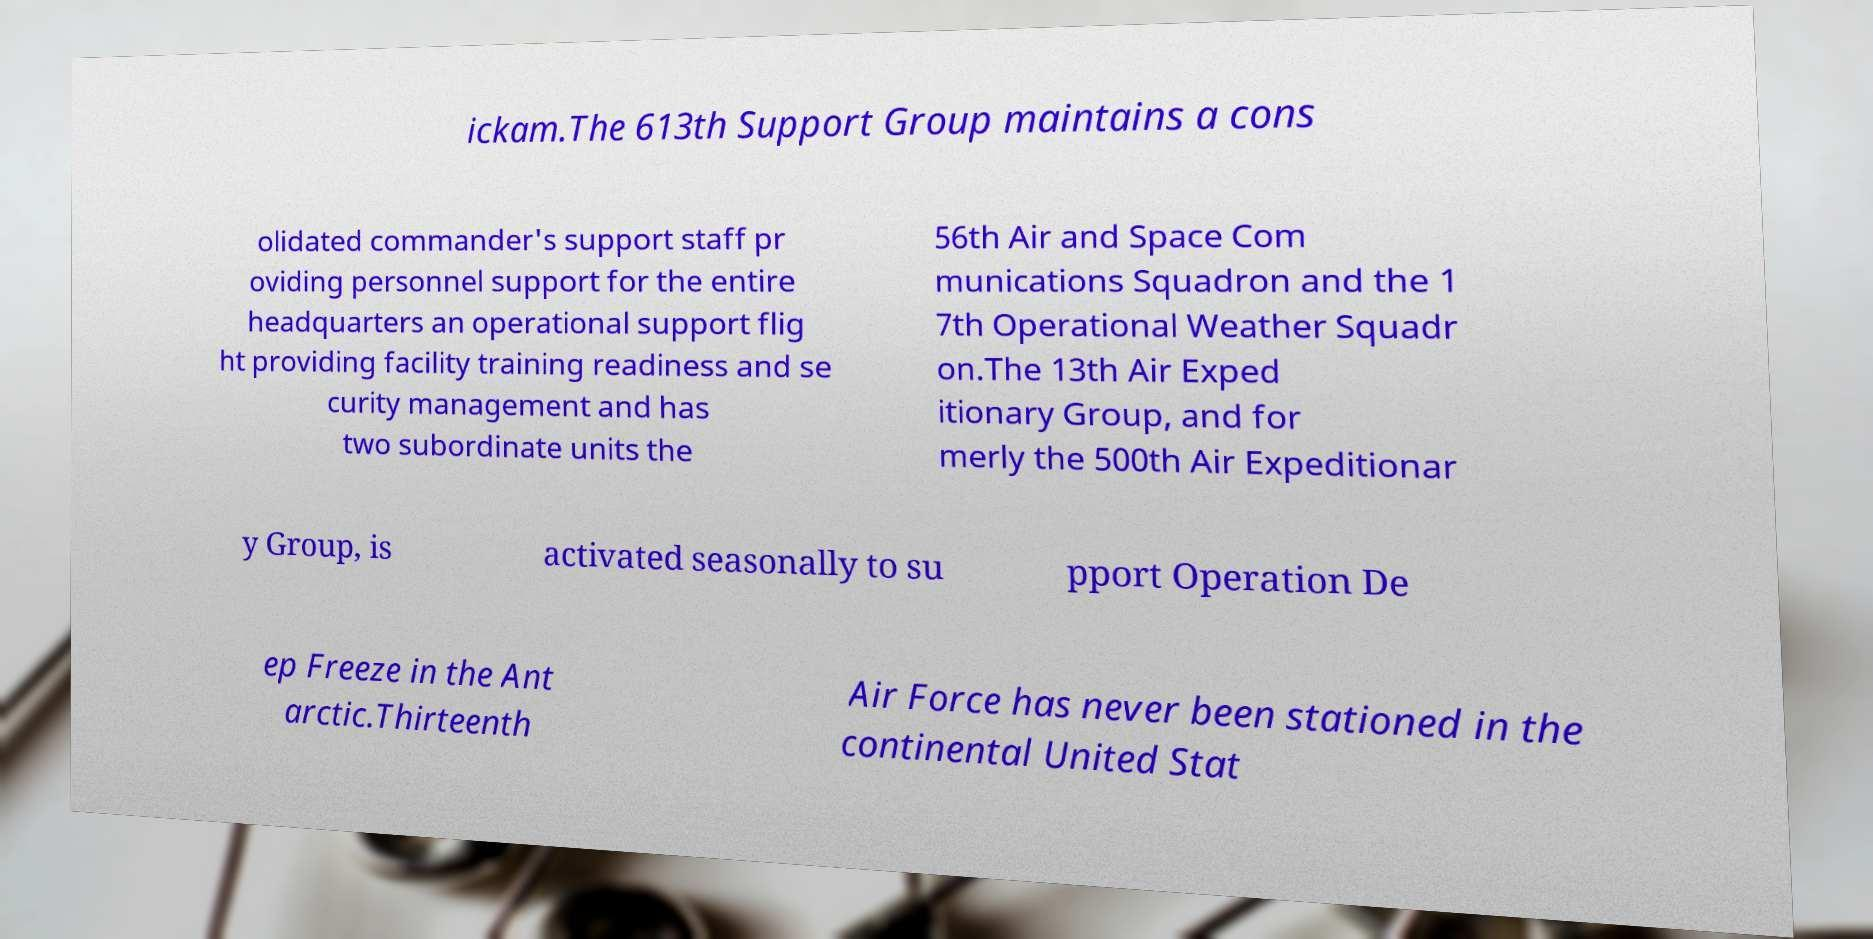For documentation purposes, I need the text within this image transcribed. Could you provide that? ickam.The 613th Support Group maintains a cons olidated commander's support staff pr oviding personnel support for the entire headquarters an operational support flig ht providing facility training readiness and se curity management and has two subordinate units the 56th Air and Space Com munications Squadron and the 1 7th Operational Weather Squadr on.The 13th Air Exped itionary Group, and for merly the 500th Air Expeditionar y Group, is activated seasonally to su pport Operation De ep Freeze in the Ant arctic.Thirteenth Air Force has never been stationed in the continental United Stat 